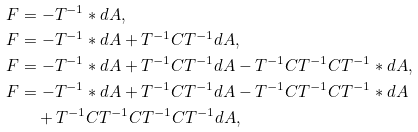Convert formula to latex. <formula><loc_0><loc_0><loc_500><loc_500>F & = - T ^ { - 1 } \ast d A , \\ F & = - T ^ { - 1 } \ast d A + T ^ { - 1 } C T ^ { - 1 } d A , \\ F & = - T ^ { - 1 } \ast d A + T ^ { - 1 } C T ^ { - 1 } d A - T ^ { - 1 } C T ^ { - 1 } C T ^ { - 1 } \ast d A , \\ F & = - T ^ { - 1 } \ast d A + T ^ { - 1 } C T ^ { - 1 } d A - T ^ { - 1 } C T ^ { - 1 } C T ^ { - 1 } \ast d A \\ & \quad + T ^ { - 1 } C T ^ { - 1 } C T ^ { - 1 } C T ^ { - 1 } d A ,</formula> 